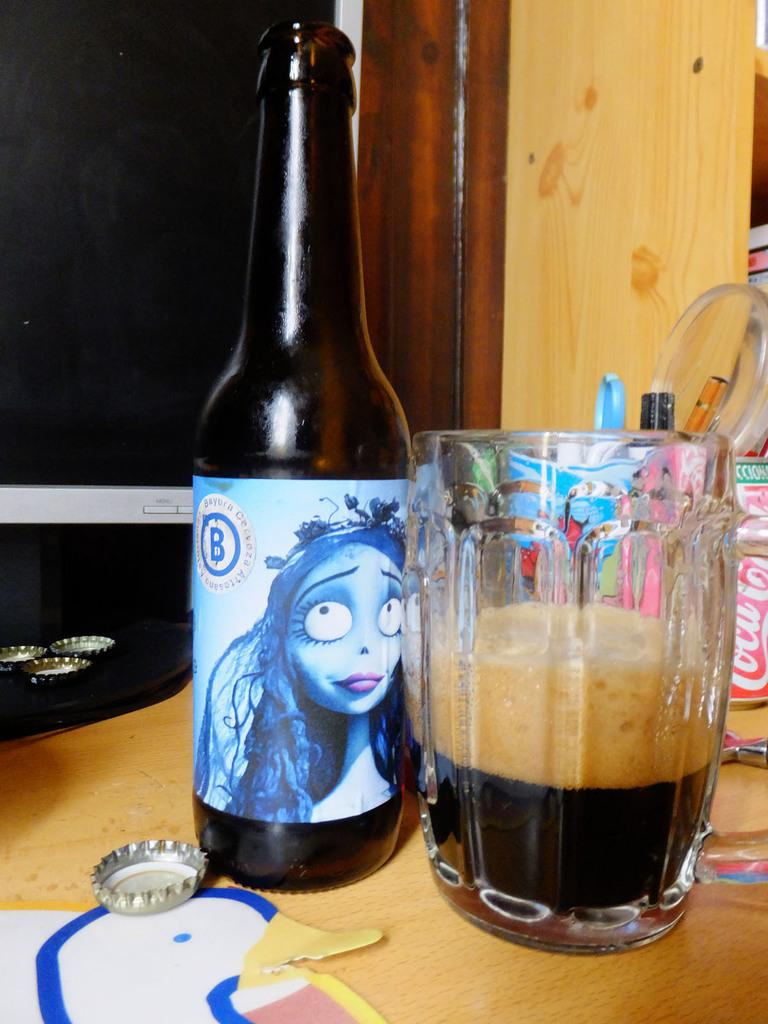<image>
Relay a brief, clear account of the picture shown. A bottle with a blue label has the letter B on it next to a half empty glass of beer 